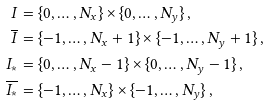<formula> <loc_0><loc_0><loc_500><loc_500>I & = \{ 0 , \dots , N _ { x } \} \times \{ 0 , \dots , N _ { y } \} \, , \\ \overline { I } & = \{ - 1 , \dots , N _ { x } + 1 \} \times \{ - 1 , \dots , N _ { y } + 1 \} \, , \\ I _ { * } & = \{ 0 , \dots , N _ { x } - 1 \} \times \{ 0 , \dots , N _ { y } - 1 \} \, , \\ \overline { I _ { * } } & = \{ - 1 , \dots , N _ { x } \} \times \{ - 1 , \dots , N _ { y } \} \, ,</formula> 